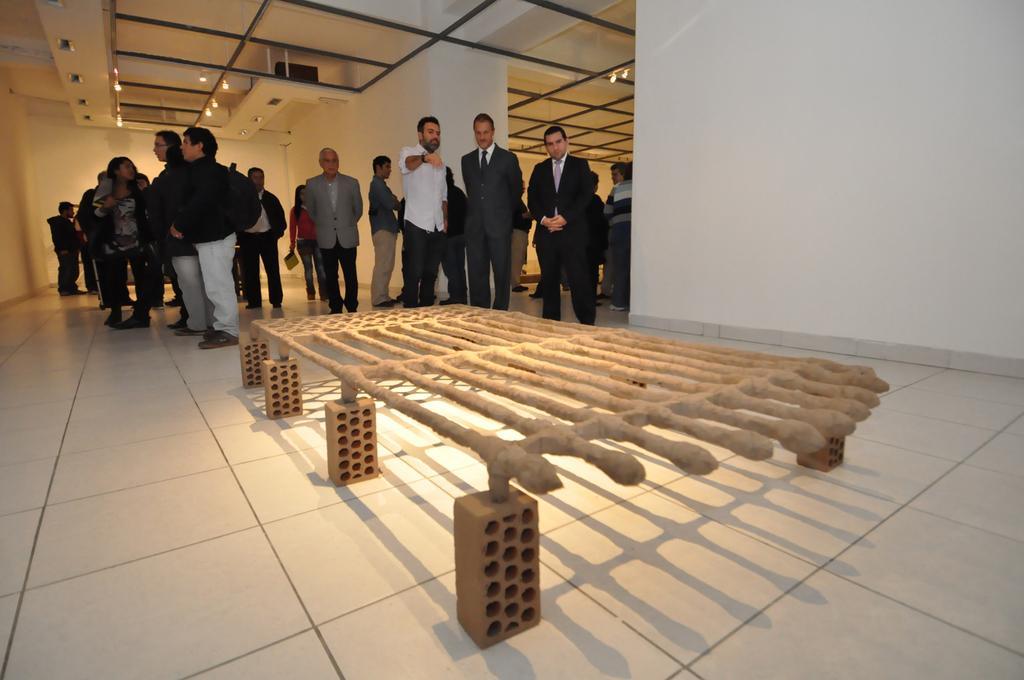Describe this image in one or two sentences. There are few persons standing and there is an object in front of them. 